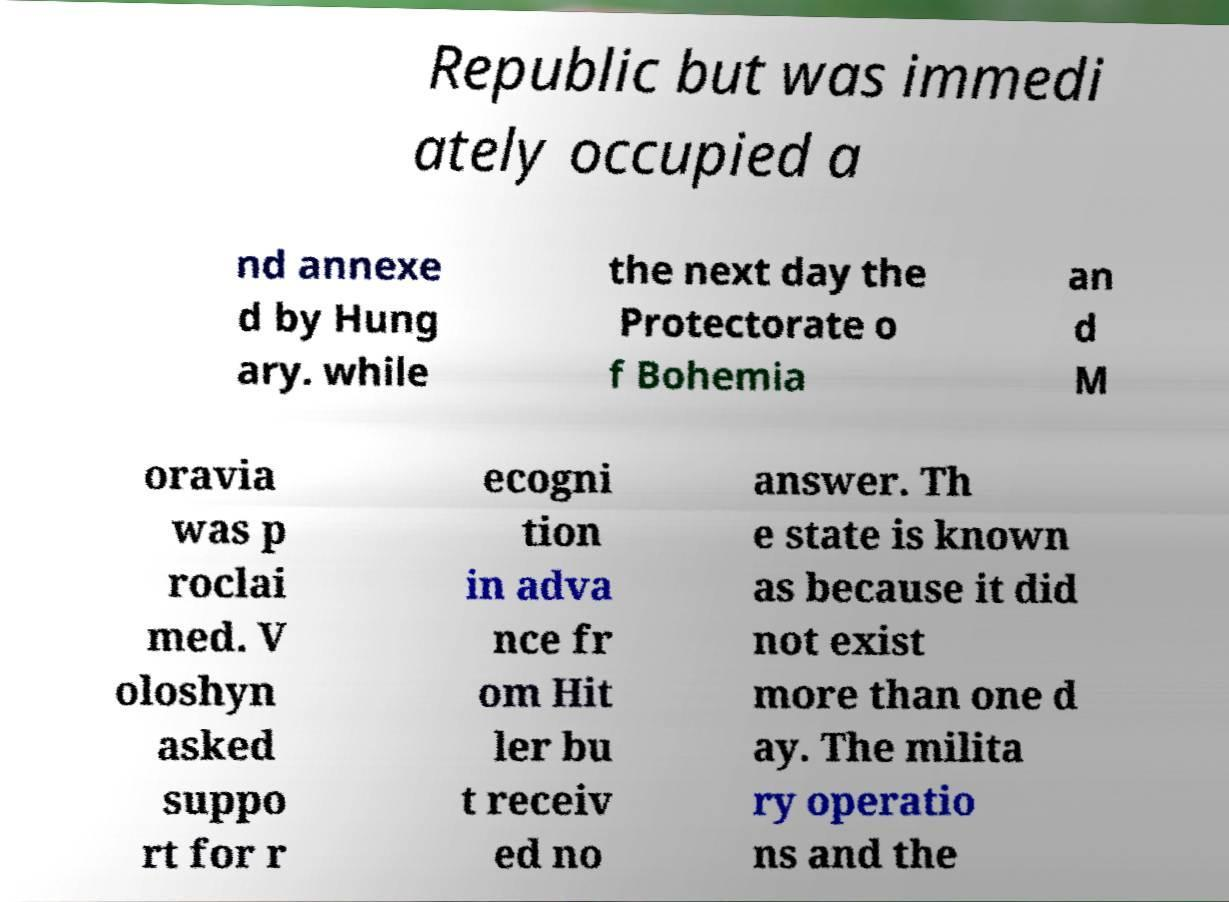What messages or text are displayed in this image? I need them in a readable, typed format. Republic but was immedi ately occupied a nd annexe d by Hung ary. while the next day the Protectorate o f Bohemia an d M oravia was p roclai med. V oloshyn asked suppo rt for r ecogni tion in adva nce fr om Hit ler bu t receiv ed no answer. Th e state is known as because it did not exist more than one d ay. The milita ry operatio ns and the 